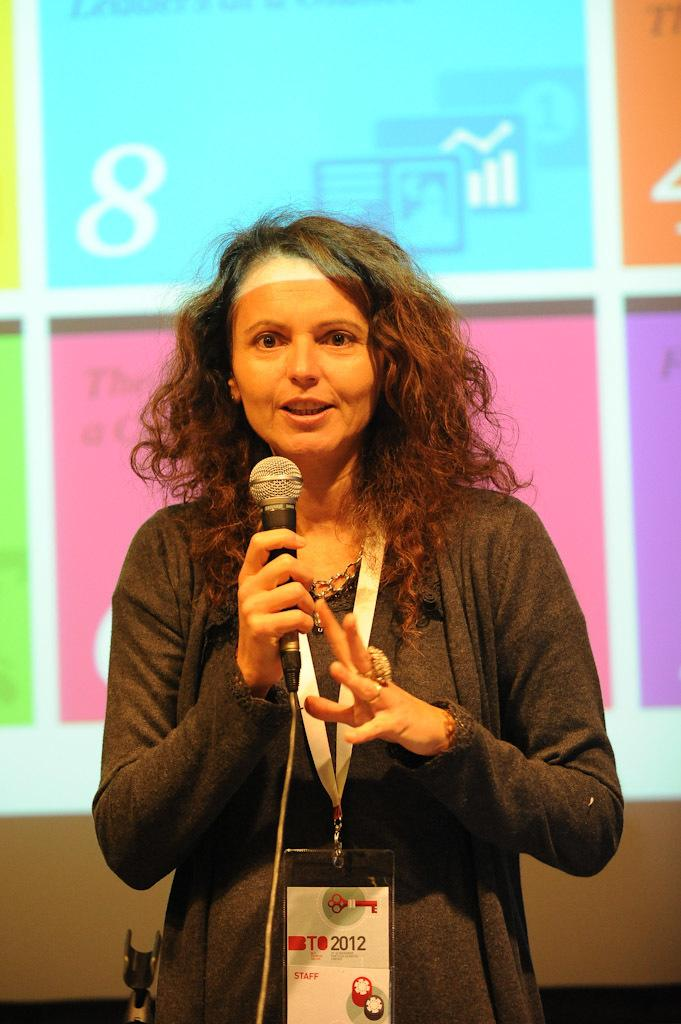What is the main subject of the image? There is a lady standing in the center of the image. What is the lady holding in the image? The lady is holding a microphone. What can be seen behind the lady in the image? There is a screen visible behind the lady. How many toes can be seen on the lady's feet in the image? The image does not show the lady's feet, so the number of toes cannot be determined. 